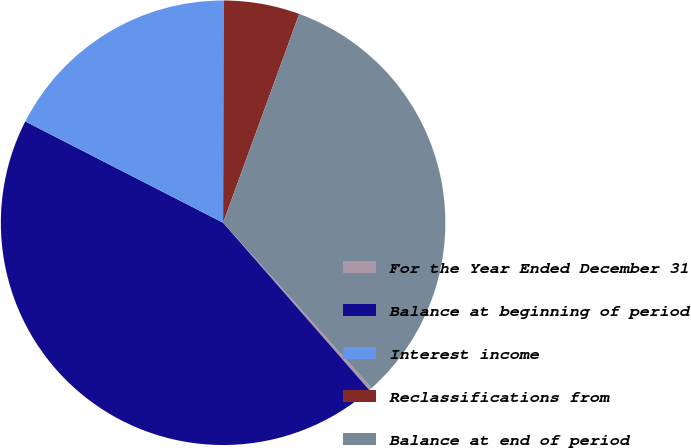Convert chart to OTSL. <chart><loc_0><loc_0><loc_500><loc_500><pie_chart><fcel>For the Year Ended December 31<fcel>Balance at beginning of period<fcel>Interest income<fcel>Reclassifications from<fcel>Balance at end of period<nl><fcel>0.22%<fcel>43.96%<fcel>17.51%<fcel>5.52%<fcel>32.79%<nl></chart> 